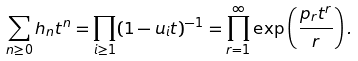<formula> <loc_0><loc_0><loc_500><loc_500>\sum _ { n \geq 0 } h _ { n } t ^ { n } = \prod _ { i \geq 1 } ( 1 - u _ { i } t ) ^ { - 1 } = \prod _ { r = 1 } ^ { \infty } \exp \left ( \frac { p _ { r } t ^ { r } } { r } \right ) .</formula> 